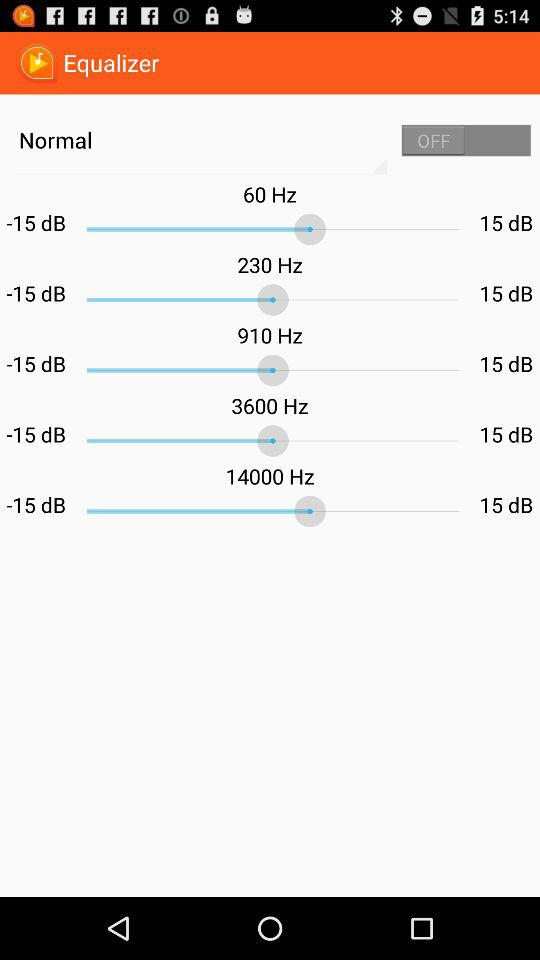What is the range in dB? The range is from -15 dB to 15 dB. 